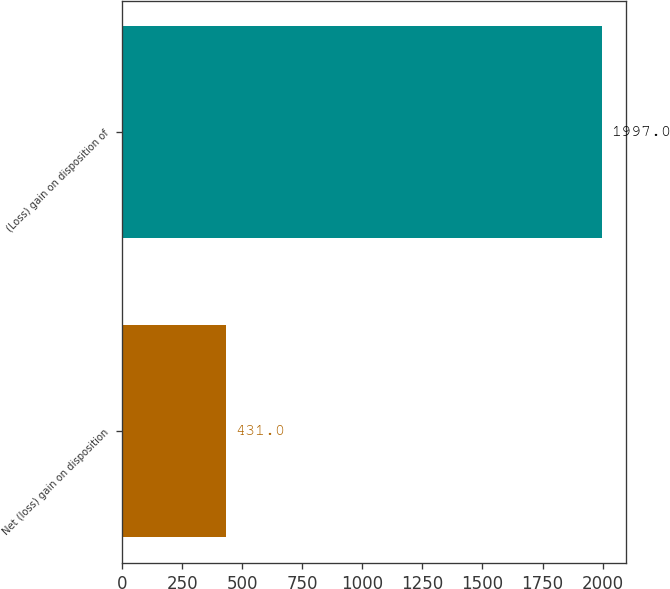Convert chart to OTSL. <chart><loc_0><loc_0><loc_500><loc_500><bar_chart><fcel>Net (loss) gain on disposition<fcel>(Loss) gain on disposition of<nl><fcel>431<fcel>1997<nl></chart> 